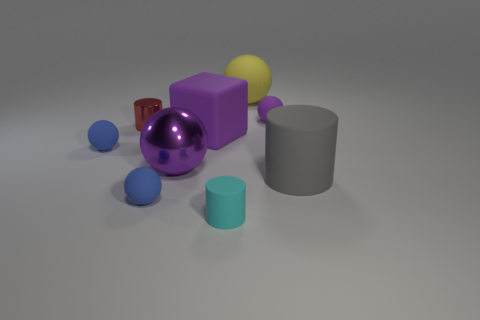Subtract all big balls. How many balls are left? 3 Subtract all purple balls. How many balls are left? 3 Subtract all blocks. How many objects are left? 8 Subtract all purple blocks. How many blue balls are left? 2 Add 1 metal cylinders. How many objects exist? 10 Subtract 1 cylinders. How many cylinders are left? 2 Subtract all yellow spheres. Subtract all purple cylinders. How many spheres are left? 4 Subtract all matte cylinders. Subtract all brown matte objects. How many objects are left? 7 Add 3 large purple balls. How many large purple balls are left? 4 Add 1 gray matte things. How many gray matte things exist? 2 